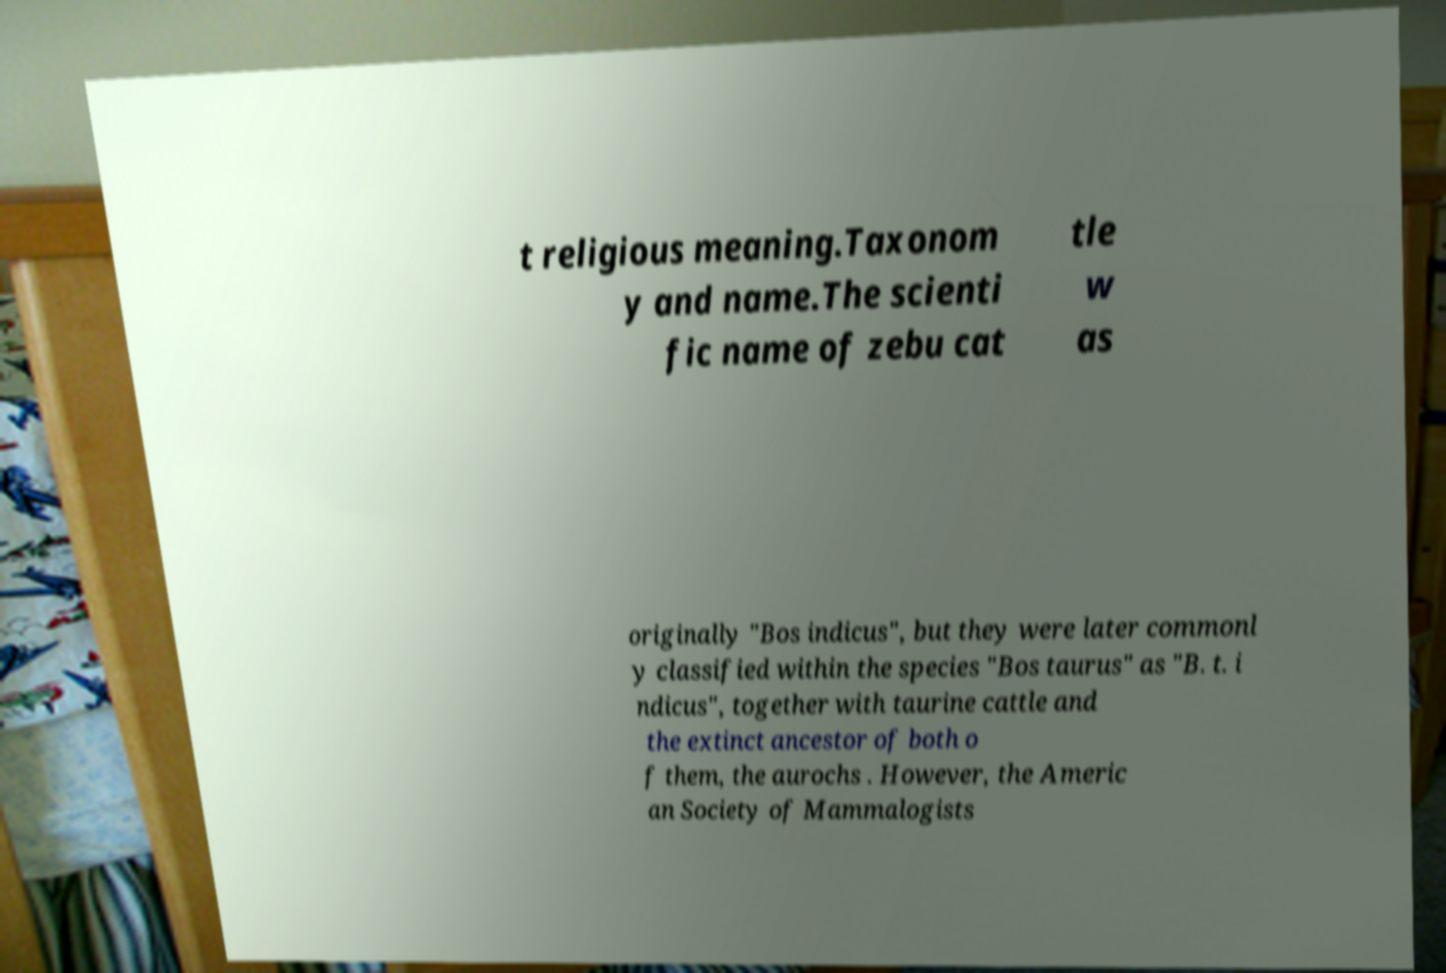Could you extract and type out the text from this image? t religious meaning.Taxonom y and name.The scienti fic name of zebu cat tle w as originally "Bos indicus", but they were later commonl y classified within the species "Bos taurus" as "B. t. i ndicus", together with taurine cattle and the extinct ancestor of both o f them, the aurochs . However, the Americ an Society of Mammalogists 